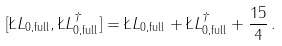<formula> <loc_0><loc_0><loc_500><loc_500>[ \L L _ { 0 , \text {full} } , \L L _ { 0 , \text {full} } ^ { \dagger } ] = \L L _ { 0 , \text {full} } + \L L _ { 0 , \text {full} } ^ { \dagger } + \frac { 1 5 } { 4 } \, .</formula> 